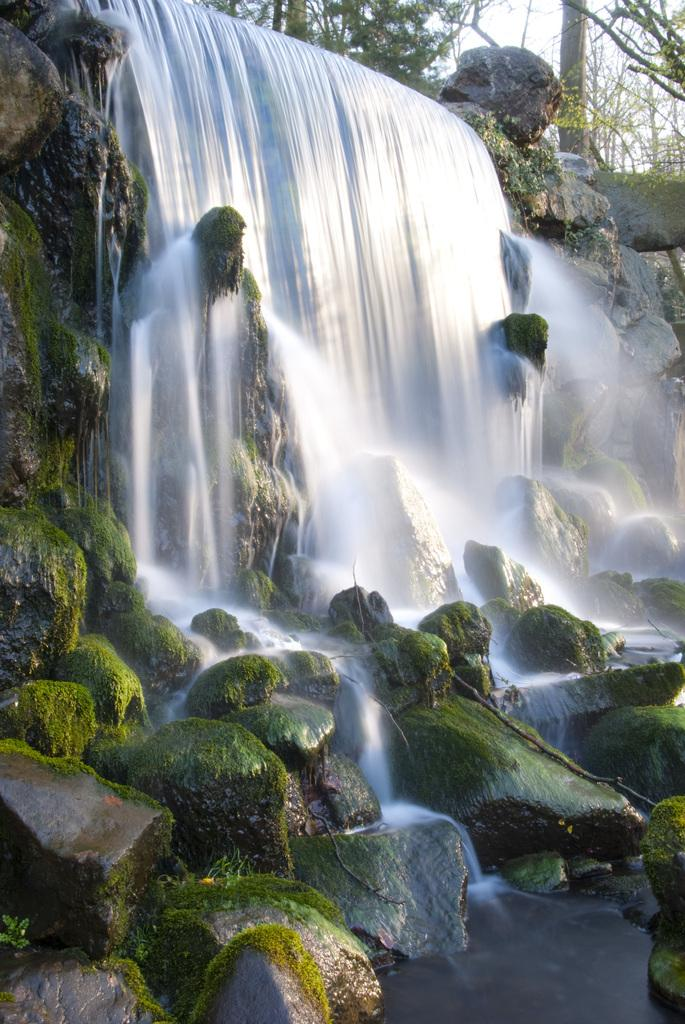What natural feature is the main subject of the image? There is a waterfall in the image. What is the waterfall situated on? The waterfall is on rocks. What type of vegetation can be seen in the background of the image? There are trees in the background of the image. What part of the natural environment is visible in the background of the image? The sky is visible in the background of the image. What song is being sung by the waterfall in the image? The waterfall is not singing a song in the image; it is a natural feature. How many cents are visible in the image? There are no cents present in the image. 